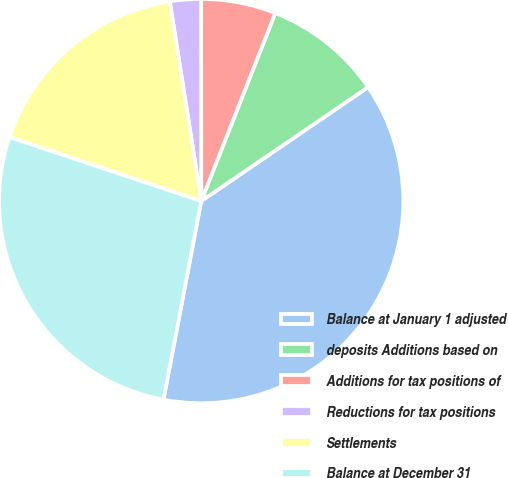Convert chart to OTSL. <chart><loc_0><loc_0><loc_500><loc_500><pie_chart><fcel>Balance at January 1 adjusted<fcel>deposits Additions based on<fcel>Additions for tax positions of<fcel>Reductions for tax positions<fcel>Settlements<fcel>Balance at December 31<nl><fcel>37.52%<fcel>9.49%<fcel>5.98%<fcel>2.48%<fcel>17.39%<fcel>27.14%<nl></chart> 